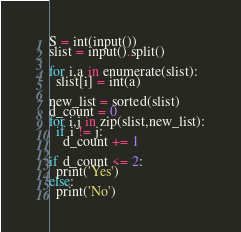Convert code to text. <code><loc_0><loc_0><loc_500><loc_500><_Python_>S = int(input())
slist = input().split()

for i,a in enumerate(slist):
  slist[i] = int(a)

new_list = sorted(slist)
d_count = 0
for i,j in zip(slist,new_list):
  if i != j:
    d_count += 1
    
if d_count <= 2:
  print('Yes')
else:
  print('No')</code> 